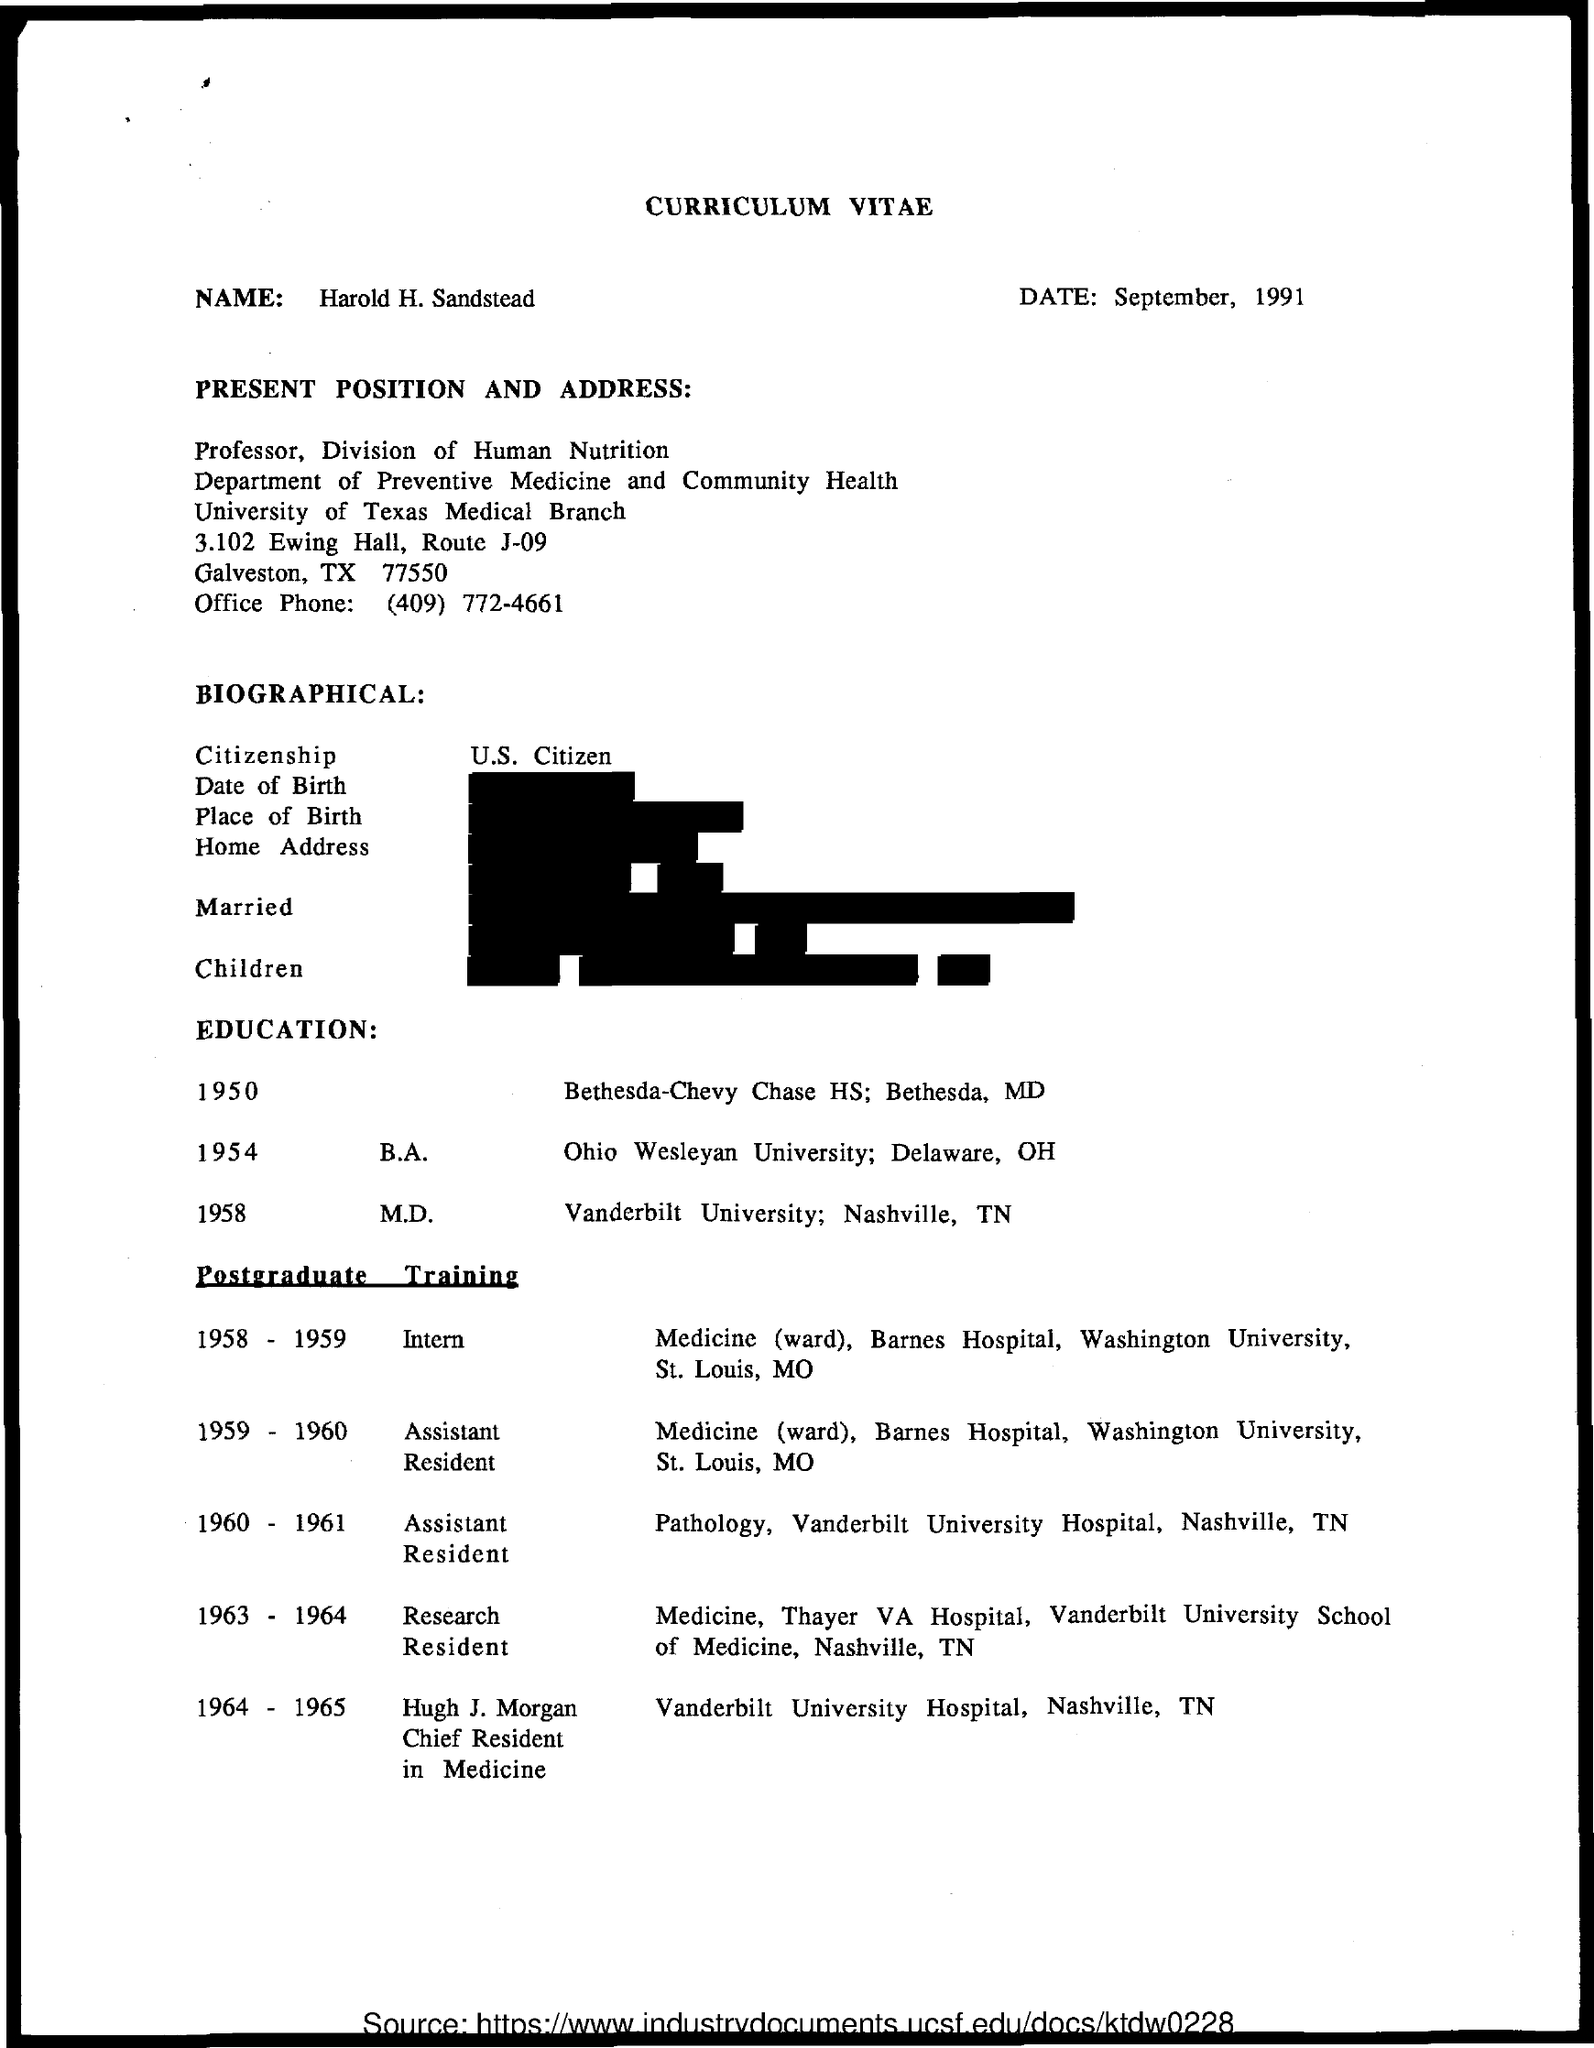Give some essential details in this illustration. The title of the document is a Curriculum Vitae. The date is September, 1991. I, [Name], am a U.S. citizen. During the years 1963 and 1964, he was a Research Resident. During the years 1958 and 1959, the individual in question served as an intern. 